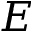<formula> <loc_0><loc_0><loc_500><loc_500>E</formula> 